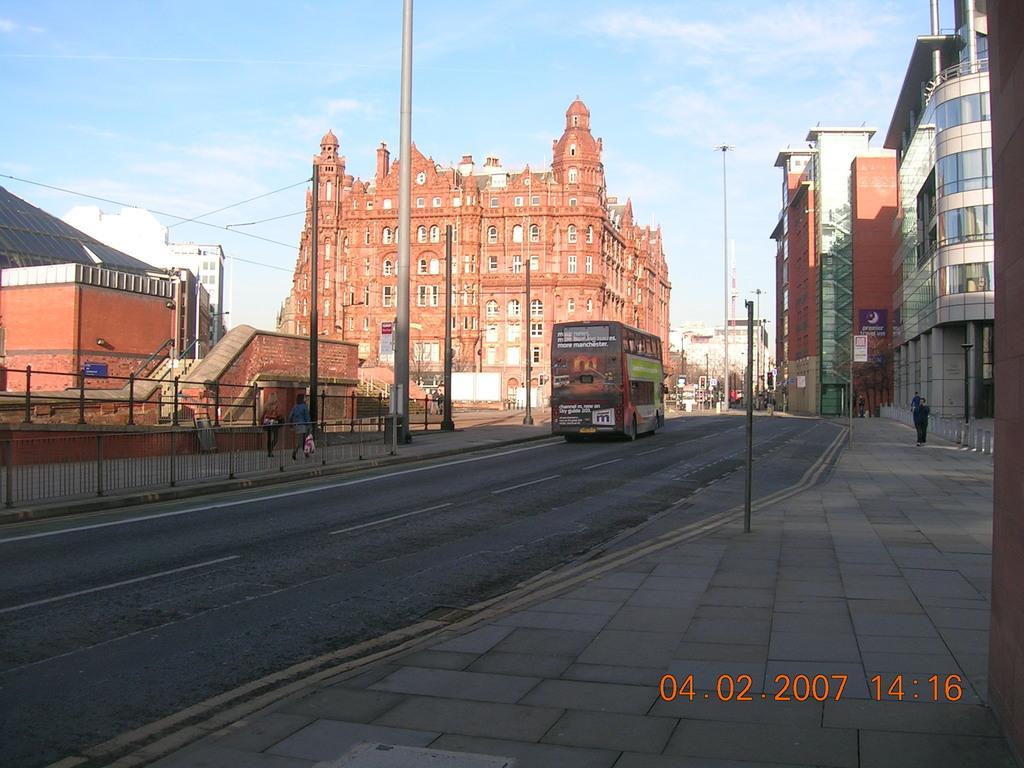In one or two sentences, can you explain what this image depicts? In this picture, we can see a few buildings, poles, stairs, railing, road, a few people, and vehicles, and the sky with clouds, and we can see date and time in bottom right side of the picture. 